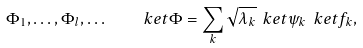Convert formula to latex. <formula><loc_0><loc_0><loc_500><loc_500>\Phi _ { 1 } , \dots , \Phi _ { l } , \dots \quad \ k e t { \Phi } = \sum _ { k } \sqrt { \lambda _ { k } } \ k e t { \psi _ { k } } \ k e t { f _ { k } } ,</formula> 